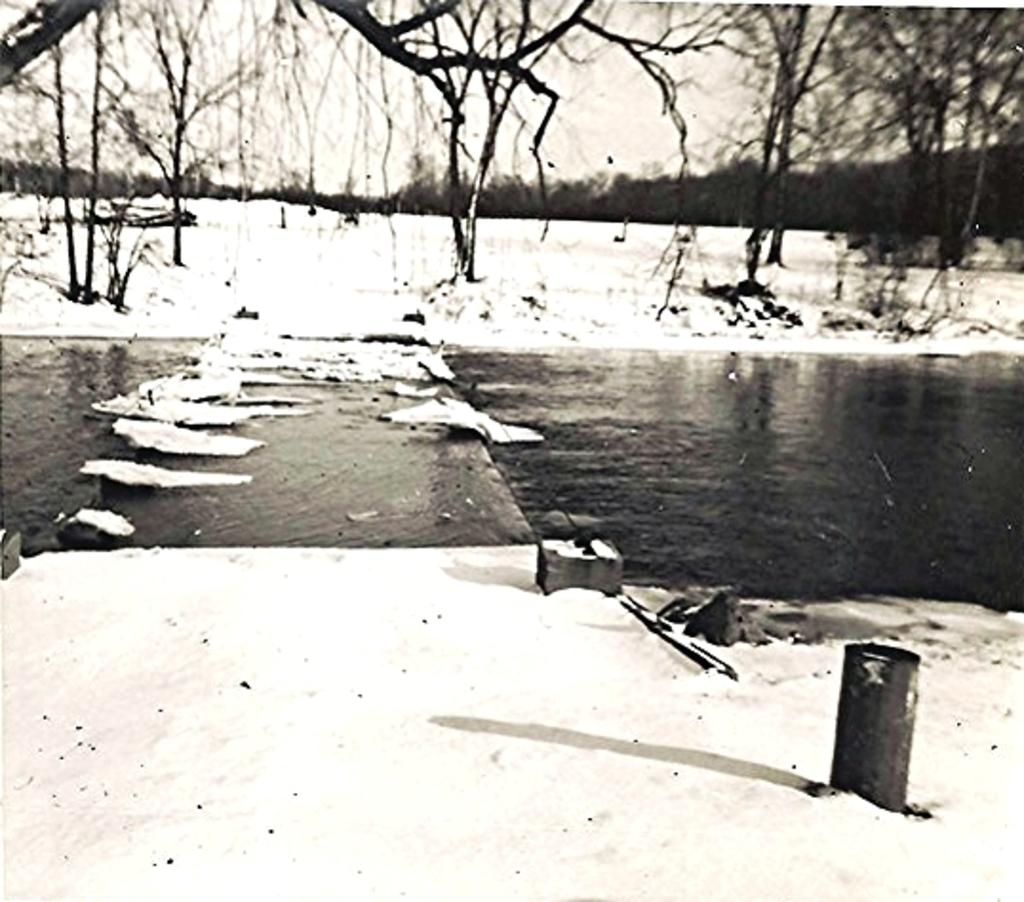What is the main feature in the center of the image? There is water in the center of the image. What type of weather condition is depicted at the top and bottom of the image? There is snow at the top and bottom side of the image. What can be seen in the background of the image? There are trees in the background area of the image. How many bulbs are hanging from the trees in the image? There are no bulbs present in the image; it features water, snow, and trees. What type of railway can be seen in the image? There is no railway present in the image. 